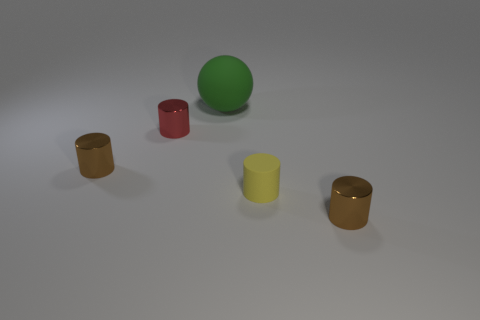Is there a purple metallic ball that has the same size as the red thing?
Your response must be concise. No. What number of objects are left of the small yellow matte cylinder and in front of the big green thing?
Provide a succinct answer. 2. What number of red cylinders are behind the yellow cylinder?
Give a very brief answer. 1. Are there any other large objects of the same shape as the red object?
Your answer should be compact. No. Do the tiny yellow matte thing and the brown thing in front of the small yellow thing have the same shape?
Provide a short and direct response. Yes. How many spheres are either big matte things or small yellow things?
Ensure brevity in your answer.  1. There is a matte object right of the large green ball; what is its shape?
Make the answer very short. Cylinder. How many cylinders have the same material as the ball?
Keep it short and to the point. 1. Is the number of yellow rubber cylinders left of the red thing less than the number of tiny yellow matte spheres?
Give a very brief answer. No. What size is the matte thing in front of the matte thing behind the tiny red metal thing?
Give a very brief answer. Small. 